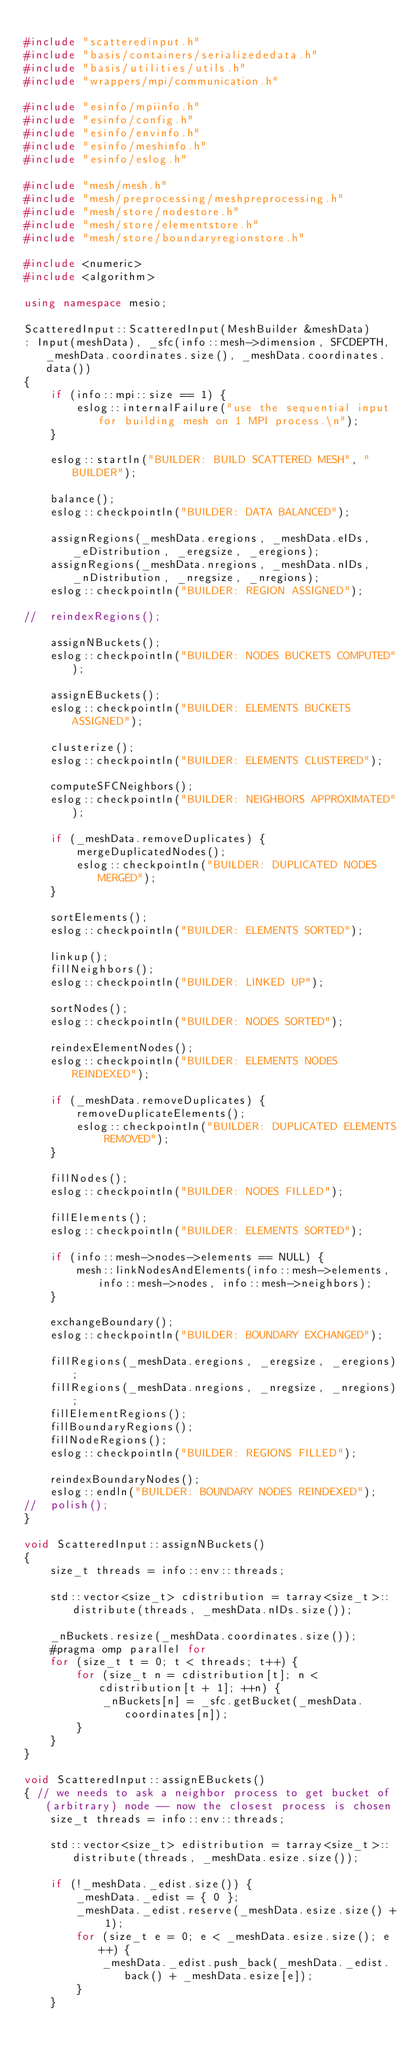Convert code to text. <code><loc_0><loc_0><loc_500><loc_500><_C++_>
#include "scatteredinput.h"
#include "basis/containers/serializededata.h"
#include "basis/utilities/utils.h"
#include "wrappers/mpi/communication.h"

#include "esinfo/mpiinfo.h"
#include "esinfo/config.h"
#include "esinfo/envinfo.h"
#include "esinfo/meshinfo.h"
#include "esinfo/eslog.h"

#include "mesh/mesh.h"
#include "mesh/preprocessing/meshpreprocessing.h"
#include "mesh/store/nodestore.h"
#include "mesh/store/elementstore.h"
#include "mesh/store/boundaryregionstore.h"

#include <numeric>
#include <algorithm>

using namespace mesio;

ScatteredInput::ScatteredInput(MeshBuilder &meshData)
: Input(meshData), _sfc(info::mesh->dimension, SFCDEPTH, _meshData.coordinates.size(), _meshData.coordinates.data())
{
	if (info::mpi::size == 1) {
		eslog::internalFailure("use the sequential input for building mesh on 1 MPI process.\n");
	}

	eslog::startln("BUILDER: BUILD SCATTERED MESH", "BUILDER");

	balance();
	eslog::checkpointln("BUILDER: DATA BALANCED");

	assignRegions(_meshData.eregions, _meshData.eIDs, _eDistribution, _eregsize, _eregions);
	assignRegions(_meshData.nregions, _meshData.nIDs, _nDistribution, _nregsize, _nregions);
	eslog::checkpointln("BUILDER: REGION ASSIGNED");

//	reindexRegions();

	assignNBuckets();
	eslog::checkpointln("BUILDER: NODES BUCKETS COMPUTED");

	assignEBuckets();
	eslog::checkpointln("BUILDER: ELEMENTS BUCKETS ASSIGNED");

	clusterize();
	eslog::checkpointln("BUILDER: ELEMENTS CLUSTERED");

	computeSFCNeighbors();
	eslog::checkpointln("BUILDER: NEIGHBORS APPROXIMATED");

	if (_meshData.removeDuplicates) {
		mergeDuplicatedNodes();
		eslog::checkpointln("BUILDER: DUPLICATED NODES MERGED");
	}

	sortElements();
	eslog::checkpointln("BUILDER: ELEMENTS SORTED");

	linkup();
	fillNeighbors();
	eslog::checkpointln("BUILDER: LINKED UP");

	sortNodes();
	eslog::checkpointln("BUILDER: NODES SORTED");

	reindexElementNodes();
	eslog::checkpointln("BUILDER: ELEMENTS NODES REINDEXED");

	if (_meshData.removeDuplicates) {
		removeDuplicateElements();
		eslog::checkpointln("BUILDER: DUPLICATED ELEMENTS REMOVED");
	}

	fillNodes();
	eslog::checkpointln("BUILDER: NODES FILLED");

	fillElements();
	eslog::checkpointln("BUILDER: ELEMENTS SORTED");

	if (info::mesh->nodes->elements == NULL) {
		mesh::linkNodesAndElements(info::mesh->elements, info::mesh->nodes, info::mesh->neighbors);
	}

	exchangeBoundary();
	eslog::checkpointln("BUILDER: BOUNDARY EXCHANGED");

	fillRegions(_meshData.eregions, _eregsize, _eregions);
	fillRegions(_meshData.nregions, _nregsize, _nregions);
	fillElementRegions();
	fillBoundaryRegions();
	fillNodeRegions();
	eslog::checkpointln("BUILDER: REGIONS FILLED");

	reindexBoundaryNodes();
	eslog::endln("BUILDER: BOUNDARY NODES REINDEXED");
//	polish();
}

void ScatteredInput::assignNBuckets()
{
	size_t threads = info::env::threads;

	std::vector<size_t> cdistribution = tarray<size_t>::distribute(threads, _meshData.nIDs.size());

	_nBuckets.resize(_meshData.coordinates.size());
	#pragma omp parallel for
	for (size_t t = 0; t < threads; t++) {
		for (size_t n = cdistribution[t]; n < cdistribution[t + 1]; ++n) {
			_nBuckets[n] = _sfc.getBucket(_meshData.coordinates[n]);
		}
	}
}

void ScatteredInput::assignEBuckets()
{ // we needs to ask a neighbor process to get bucket of (arbitrary) node -- now the closest process is chosen
	size_t threads = info::env::threads;

	std::vector<size_t> edistribution = tarray<size_t>::distribute(threads, _meshData.esize.size());

	if (!_meshData._edist.size()) {
		_meshData._edist = { 0 };
		_meshData._edist.reserve(_meshData.esize.size() + 1);
		for (size_t e = 0; e < _meshData.esize.size(); e++) {
			_meshData._edist.push_back(_meshData._edist.back() + _meshData.esize[e]);
		}
	}
</code> 